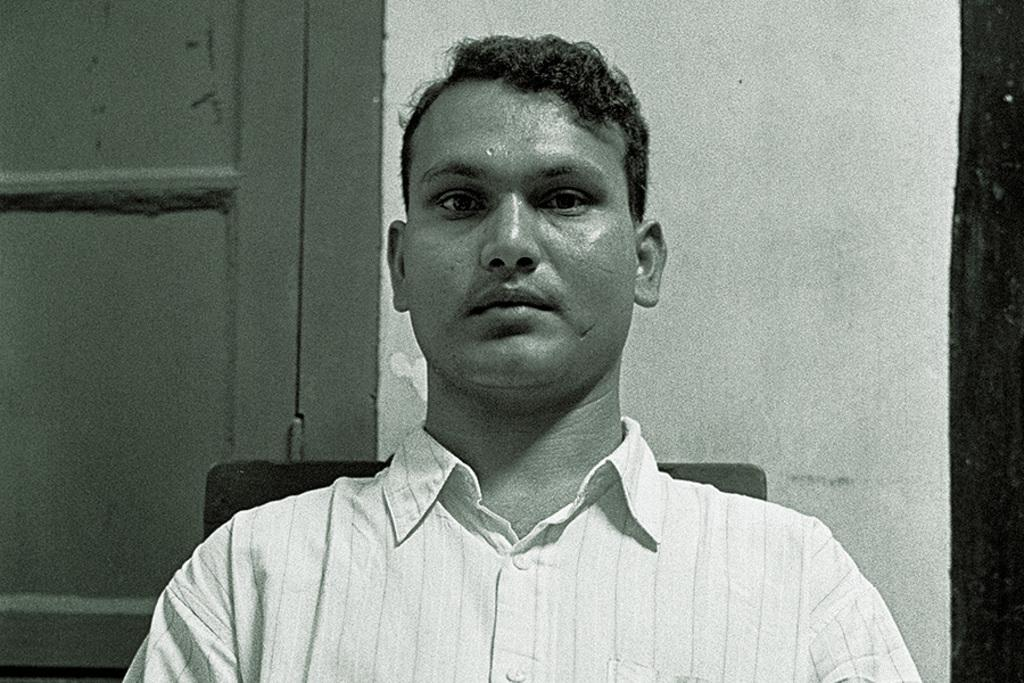What is the man in the image doing? The man is sitting in the image. What can be seen in the background of the image? There is a wall and a door in the background of the image. What type of throne is the man sitting on in the image? There is no throne present in the image; the man is sitting on a regular chair or surface. What type of stretch can be seen in the image? There is no stretch present in the image; it is a static scene with a man sitting and a background with a wall and a door. 